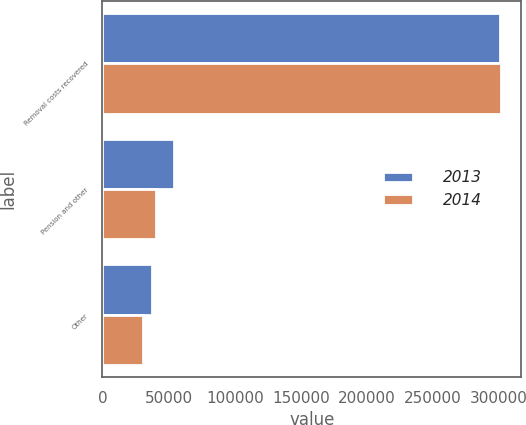Convert chart to OTSL. <chart><loc_0><loc_0><loc_500><loc_500><stacked_bar_chart><ecel><fcel>Removal costs recovered<fcel>Pension and other<fcel>Other<nl><fcel>2013<fcel>300635<fcel>53734<fcel>37413<nl><fcel>2014<fcel>301537<fcel>40837<fcel>30945<nl></chart> 